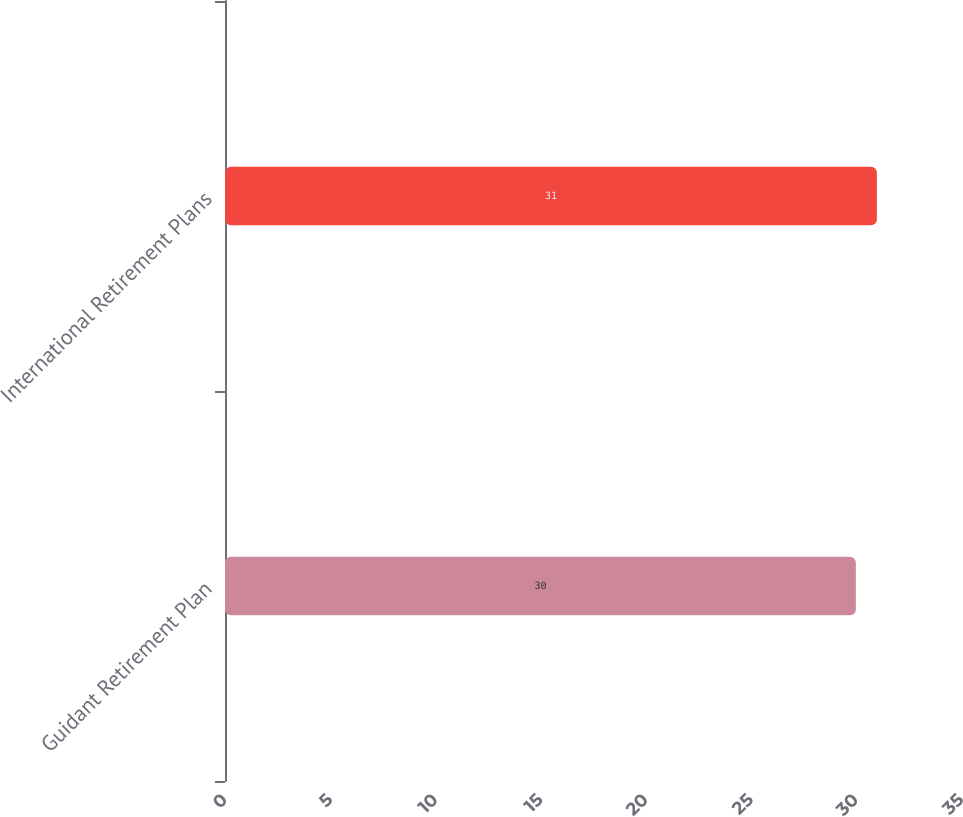<chart> <loc_0><loc_0><loc_500><loc_500><bar_chart><fcel>Guidant Retirement Plan<fcel>International Retirement Plans<nl><fcel>30<fcel>31<nl></chart> 